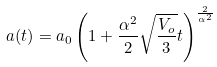Convert formula to latex. <formula><loc_0><loc_0><loc_500><loc_500>a ( t ) = a _ { 0 } \left ( 1 + \frac { \alpha ^ { 2 } } { 2 } \sqrt { \frac { V _ { o } } { 3 } } t \right ) ^ { \frac { 2 } { \alpha ^ { 2 } } }</formula> 